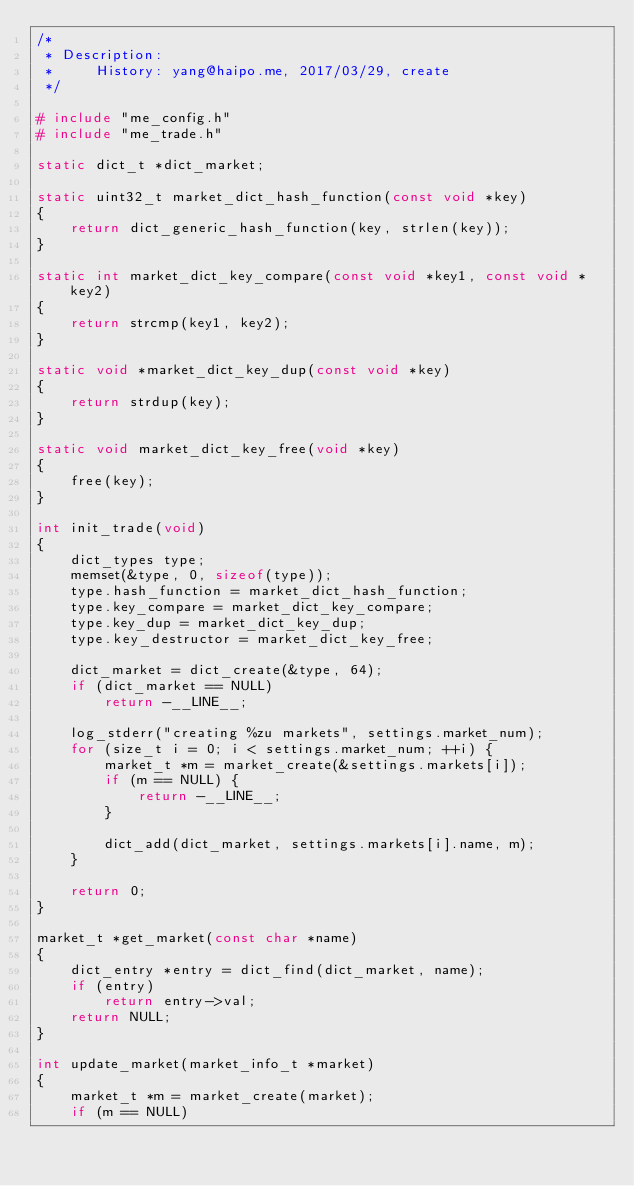<code> <loc_0><loc_0><loc_500><loc_500><_C_>/*
 * Description: 
 *     History: yang@haipo.me, 2017/03/29, create
 */

# include "me_config.h"
# include "me_trade.h"

static dict_t *dict_market;

static uint32_t market_dict_hash_function(const void *key)
{
    return dict_generic_hash_function(key, strlen(key));
}

static int market_dict_key_compare(const void *key1, const void *key2)
{
    return strcmp(key1, key2);
}

static void *market_dict_key_dup(const void *key)
{
    return strdup(key);
}

static void market_dict_key_free(void *key)
{
    free(key);
}

int init_trade(void)
{
    dict_types type;
    memset(&type, 0, sizeof(type));
    type.hash_function = market_dict_hash_function;
    type.key_compare = market_dict_key_compare;
    type.key_dup = market_dict_key_dup;
    type.key_destructor = market_dict_key_free;

    dict_market = dict_create(&type, 64);
    if (dict_market == NULL)
        return -__LINE__;

    log_stderr("creating %zu markets", settings.market_num);
    for (size_t i = 0; i < settings.market_num; ++i) {
        market_t *m = market_create(&settings.markets[i]);
        if (m == NULL) {
            return -__LINE__;
        }

        dict_add(dict_market, settings.markets[i].name, m);
    }

    return 0;
}

market_t *get_market(const char *name)
{
    dict_entry *entry = dict_find(dict_market, name);
    if (entry)
        return entry->val;
    return NULL;
}

int update_market(market_info_t *market)
{
    market_t *m = market_create(market);
    if (m == NULL)</code> 